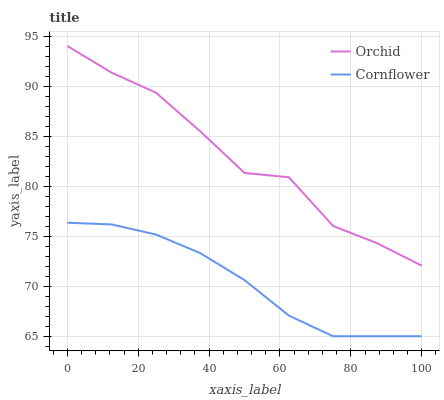Does Cornflower have the minimum area under the curve?
Answer yes or no. Yes. Does Orchid have the maximum area under the curve?
Answer yes or no. Yes. Does Orchid have the minimum area under the curve?
Answer yes or no. No. Is Cornflower the smoothest?
Answer yes or no. Yes. Is Orchid the roughest?
Answer yes or no. Yes. Is Orchid the smoothest?
Answer yes or no. No. Does Cornflower have the lowest value?
Answer yes or no. Yes. Does Orchid have the lowest value?
Answer yes or no. No. Does Orchid have the highest value?
Answer yes or no. Yes. Is Cornflower less than Orchid?
Answer yes or no. Yes. Is Orchid greater than Cornflower?
Answer yes or no. Yes. Does Cornflower intersect Orchid?
Answer yes or no. No. 